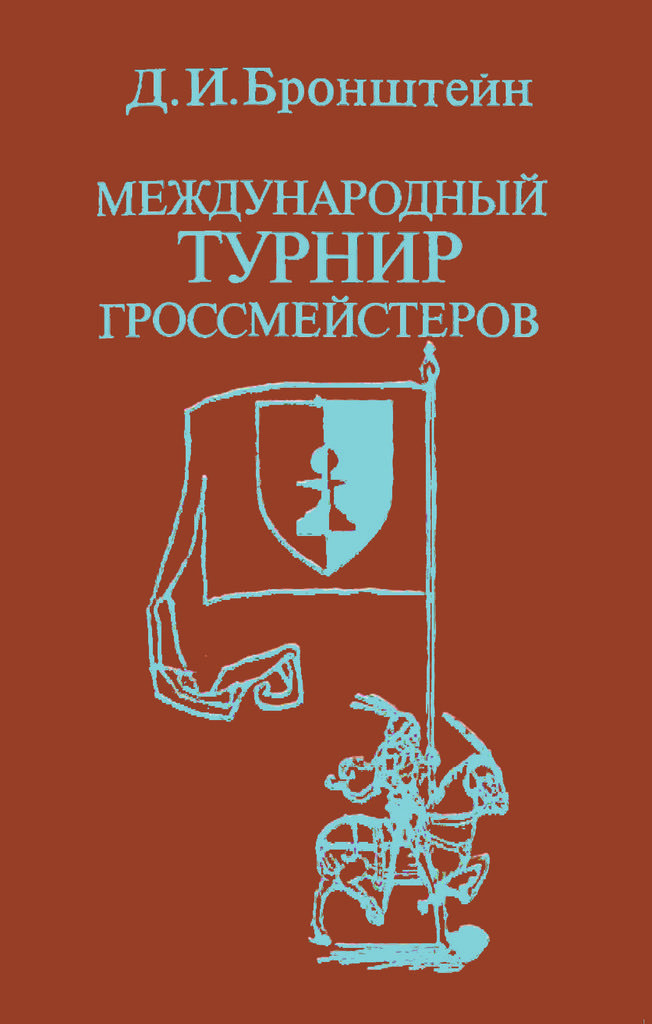What is depicted on the poster in the image? The poster contains a horse. Is there anyone riding the horse on the poster? Yes, there is a man on the horse. What is the man holding on the poster? The man is holding a flag. What can be seen at the top of the poster? There is text written at the top of the poster. Can you tell me how many liquid containers are visible on the dock in the image? There is no dock or liquid containers present in the image; it features a poster with a man, a horse, a flag, and text. 